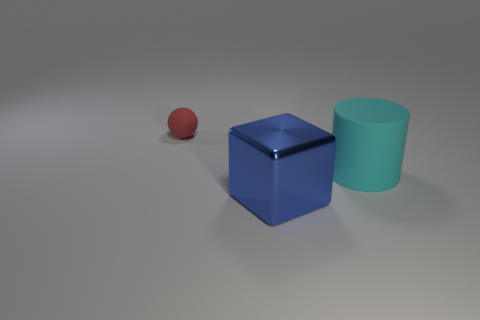What material is the cyan cylinder?
Offer a terse response. Rubber. There is a thing that is both right of the tiny matte thing and behind the shiny cube; what is its color?
Your response must be concise. Cyan. Is there any other thing that has the same material as the big blue block?
Your answer should be compact. No. Does the tiny red object have the same material as the thing in front of the rubber cylinder?
Your response must be concise. No. What is the size of the matte thing that is on the left side of the object that is right of the big blue metallic block?
Offer a terse response. Small. Is the object that is in front of the big rubber cylinder made of the same material as the thing behind the large cyan cylinder?
Provide a short and direct response. No. There is a thing that is on the left side of the large cylinder and to the right of the red matte sphere; what is it made of?
Your answer should be very brief. Metal. There is a object on the left side of the big thing that is in front of the matte object that is to the right of the tiny red rubber thing; what is it made of?
Give a very brief answer. Rubber. What number of other objects are the same size as the blue metal block?
Your response must be concise. 1. There is a matte thing that is left of the large thing that is on the left side of the cylinder; how many tiny red balls are left of it?
Provide a short and direct response. 0. 